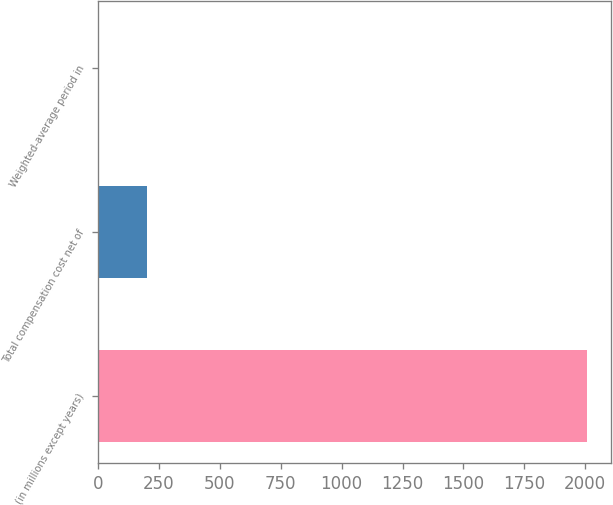Convert chart. <chart><loc_0><loc_0><loc_500><loc_500><bar_chart><fcel>(in millions except years)<fcel>Total compensation cost net of<fcel>Weighted-average period in<nl><fcel>2008<fcel>202.51<fcel>1.9<nl></chart> 